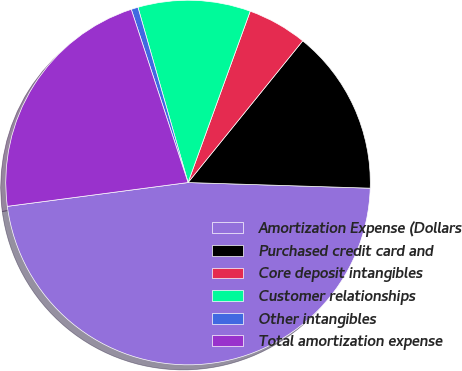<chart> <loc_0><loc_0><loc_500><loc_500><pie_chart><fcel>Amortization Expense (Dollars<fcel>Purchased credit card and<fcel>Core deposit intangibles<fcel>Customer relationships<fcel>Other intangibles<fcel>Total amortization expense<nl><fcel>47.42%<fcel>14.66%<fcel>5.29%<fcel>9.97%<fcel>0.61%<fcel>22.04%<nl></chart> 